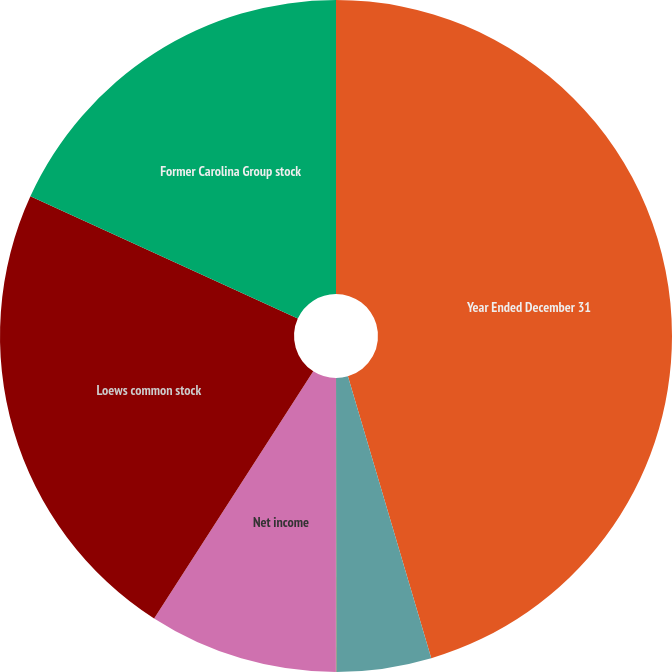<chart> <loc_0><loc_0><loc_500><loc_500><pie_chart><fcel>Year Ended December 31<fcel>Income (loss) from continuing<fcel>Discontinued operations net<fcel>Net income<fcel>Loews common stock<fcel>Former Carolina Group stock<nl><fcel>45.43%<fcel>4.56%<fcel>0.02%<fcel>9.1%<fcel>22.72%<fcel>18.18%<nl></chart> 